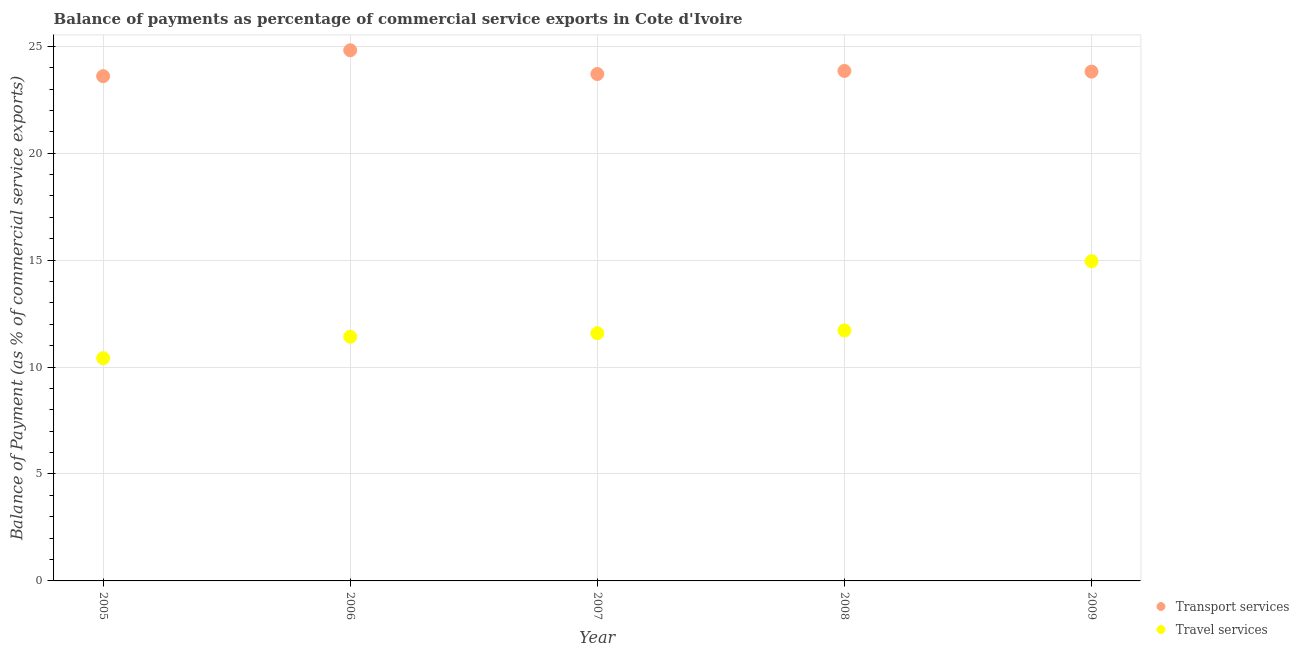Is the number of dotlines equal to the number of legend labels?
Offer a very short reply. Yes. What is the balance of payments of transport services in 2009?
Offer a very short reply. 23.82. Across all years, what is the maximum balance of payments of travel services?
Offer a terse response. 14.95. Across all years, what is the minimum balance of payments of transport services?
Offer a very short reply. 23.6. In which year was the balance of payments of transport services maximum?
Your answer should be compact. 2006. What is the total balance of payments of travel services in the graph?
Provide a short and direct response. 60.08. What is the difference between the balance of payments of transport services in 2005 and that in 2006?
Your response must be concise. -1.21. What is the difference between the balance of payments of transport services in 2007 and the balance of payments of travel services in 2006?
Give a very brief answer. 12.29. What is the average balance of payments of transport services per year?
Your answer should be compact. 23.96. In the year 2008, what is the difference between the balance of payments of travel services and balance of payments of transport services?
Give a very brief answer. -12.13. In how many years, is the balance of payments of travel services greater than 15 %?
Your answer should be very brief. 0. What is the ratio of the balance of payments of transport services in 2007 to that in 2009?
Your answer should be compact. 1. Is the balance of payments of travel services in 2006 less than that in 2008?
Offer a very short reply. Yes. What is the difference between the highest and the second highest balance of payments of transport services?
Your answer should be very brief. 0.97. What is the difference between the highest and the lowest balance of payments of travel services?
Offer a very short reply. 4.54. In how many years, is the balance of payments of transport services greater than the average balance of payments of transport services taken over all years?
Your response must be concise. 1. Is the sum of the balance of payments of transport services in 2007 and 2009 greater than the maximum balance of payments of travel services across all years?
Your answer should be very brief. Yes. Is the balance of payments of transport services strictly less than the balance of payments of travel services over the years?
Keep it short and to the point. No. How many years are there in the graph?
Your answer should be very brief. 5. Are the values on the major ticks of Y-axis written in scientific E-notation?
Ensure brevity in your answer.  No. Where does the legend appear in the graph?
Provide a succinct answer. Bottom right. What is the title of the graph?
Keep it short and to the point. Balance of payments as percentage of commercial service exports in Cote d'Ivoire. Does "Transport services" appear as one of the legend labels in the graph?
Make the answer very short. Yes. What is the label or title of the X-axis?
Provide a succinct answer. Year. What is the label or title of the Y-axis?
Ensure brevity in your answer.  Balance of Payment (as % of commercial service exports). What is the Balance of Payment (as % of commercial service exports) in Transport services in 2005?
Offer a terse response. 23.6. What is the Balance of Payment (as % of commercial service exports) in Travel services in 2005?
Ensure brevity in your answer.  10.42. What is the Balance of Payment (as % of commercial service exports) of Transport services in 2006?
Ensure brevity in your answer.  24.81. What is the Balance of Payment (as % of commercial service exports) of Travel services in 2006?
Provide a succinct answer. 11.42. What is the Balance of Payment (as % of commercial service exports) of Transport services in 2007?
Provide a short and direct response. 23.7. What is the Balance of Payment (as % of commercial service exports) of Travel services in 2007?
Your answer should be very brief. 11.58. What is the Balance of Payment (as % of commercial service exports) of Transport services in 2008?
Provide a succinct answer. 23.85. What is the Balance of Payment (as % of commercial service exports) of Travel services in 2008?
Offer a terse response. 11.72. What is the Balance of Payment (as % of commercial service exports) in Transport services in 2009?
Your answer should be very brief. 23.82. What is the Balance of Payment (as % of commercial service exports) of Travel services in 2009?
Provide a short and direct response. 14.95. Across all years, what is the maximum Balance of Payment (as % of commercial service exports) in Transport services?
Your response must be concise. 24.81. Across all years, what is the maximum Balance of Payment (as % of commercial service exports) of Travel services?
Your answer should be very brief. 14.95. Across all years, what is the minimum Balance of Payment (as % of commercial service exports) in Transport services?
Provide a succinct answer. 23.6. Across all years, what is the minimum Balance of Payment (as % of commercial service exports) of Travel services?
Provide a short and direct response. 10.42. What is the total Balance of Payment (as % of commercial service exports) in Transport services in the graph?
Make the answer very short. 119.79. What is the total Balance of Payment (as % of commercial service exports) of Travel services in the graph?
Your answer should be very brief. 60.08. What is the difference between the Balance of Payment (as % of commercial service exports) of Transport services in 2005 and that in 2006?
Provide a short and direct response. -1.21. What is the difference between the Balance of Payment (as % of commercial service exports) of Transport services in 2005 and that in 2007?
Your answer should be compact. -0.1. What is the difference between the Balance of Payment (as % of commercial service exports) in Travel services in 2005 and that in 2007?
Your answer should be very brief. -1.16. What is the difference between the Balance of Payment (as % of commercial service exports) of Transport services in 2005 and that in 2008?
Provide a succinct answer. -0.24. What is the difference between the Balance of Payment (as % of commercial service exports) in Travel services in 2005 and that in 2008?
Keep it short and to the point. -1.3. What is the difference between the Balance of Payment (as % of commercial service exports) in Transport services in 2005 and that in 2009?
Make the answer very short. -0.21. What is the difference between the Balance of Payment (as % of commercial service exports) of Travel services in 2005 and that in 2009?
Keep it short and to the point. -4.54. What is the difference between the Balance of Payment (as % of commercial service exports) in Transport services in 2006 and that in 2007?
Offer a very short reply. 1.11. What is the difference between the Balance of Payment (as % of commercial service exports) in Travel services in 2006 and that in 2007?
Offer a very short reply. -0.17. What is the difference between the Balance of Payment (as % of commercial service exports) in Transport services in 2006 and that in 2008?
Keep it short and to the point. 0.97. What is the difference between the Balance of Payment (as % of commercial service exports) in Travel services in 2006 and that in 2008?
Keep it short and to the point. -0.3. What is the difference between the Balance of Payment (as % of commercial service exports) of Transport services in 2006 and that in 2009?
Give a very brief answer. 1. What is the difference between the Balance of Payment (as % of commercial service exports) of Travel services in 2006 and that in 2009?
Make the answer very short. -3.54. What is the difference between the Balance of Payment (as % of commercial service exports) of Transport services in 2007 and that in 2008?
Keep it short and to the point. -0.14. What is the difference between the Balance of Payment (as % of commercial service exports) of Travel services in 2007 and that in 2008?
Keep it short and to the point. -0.13. What is the difference between the Balance of Payment (as % of commercial service exports) of Transport services in 2007 and that in 2009?
Keep it short and to the point. -0.11. What is the difference between the Balance of Payment (as % of commercial service exports) in Travel services in 2007 and that in 2009?
Your answer should be very brief. -3.37. What is the difference between the Balance of Payment (as % of commercial service exports) in Transport services in 2008 and that in 2009?
Ensure brevity in your answer.  0.03. What is the difference between the Balance of Payment (as % of commercial service exports) in Travel services in 2008 and that in 2009?
Your answer should be very brief. -3.24. What is the difference between the Balance of Payment (as % of commercial service exports) of Transport services in 2005 and the Balance of Payment (as % of commercial service exports) of Travel services in 2006?
Provide a succinct answer. 12.19. What is the difference between the Balance of Payment (as % of commercial service exports) in Transport services in 2005 and the Balance of Payment (as % of commercial service exports) in Travel services in 2007?
Your answer should be compact. 12.02. What is the difference between the Balance of Payment (as % of commercial service exports) in Transport services in 2005 and the Balance of Payment (as % of commercial service exports) in Travel services in 2008?
Your answer should be compact. 11.89. What is the difference between the Balance of Payment (as % of commercial service exports) of Transport services in 2005 and the Balance of Payment (as % of commercial service exports) of Travel services in 2009?
Give a very brief answer. 8.65. What is the difference between the Balance of Payment (as % of commercial service exports) in Transport services in 2006 and the Balance of Payment (as % of commercial service exports) in Travel services in 2007?
Offer a very short reply. 13.23. What is the difference between the Balance of Payment (as % of commercial service exports) in Transport services in 2006 and the Balance of Payment (as % of commercial service exports) in Travel services in 2008?
Provide a succinct answer. 13.1. What is the difference between the Balance of Payment (as % of commercial service exports) of Transport services in 2006 and the Balance of Payment (as % of commercial service exports) of Travel services in 2009?
Offer a terse response. 9.86. What is the difference between the Balance of Payment (as % of commercial service exports) of Transport services in 2007 and the Balance of Payment (as % of commercial service exports) of Travel services in 2008?
Provide a short and direct response. 11.99. What is the difference between the Balance of Payment (as % of commercial service exports) in Transport services in 2007 and the Balance of Payment (as % of commercial service exports) in Travel services in 2009?
Your response must be concise. 8.75. What is the difference between the Balance of Payment (as % of commercial service exports) in Transport services in 2008 and the Balance of Payment (as % of commercial service exports) in Travel services in 2009?
Your answer should be compact. 8.9. What is the average Balance of Payment (as % of commercial service exports) of Transport services per year?
Offer a very short reply. 23.96. What is the average Balance of Payment (as % of commercial service exports) in Travel services per year?
Make the answer very short. 12.02. In the year 2005, what is the difference between the Balance of Payment (as % of commercial service exports) of Transport services and Balance of Payment (as % of commercial service exports) of Travel services?
Keep it short and to the point. 13.19. In the year 2006, what is the difference between the Balance of Payment (as % of commercial service exports) in Transport services and Balance of Payment (as % of commercial service exports) in Travel services?
Your answer should be very brief. 13.4. In the year 2007, what is the difference between the Balance of Payment (as % of commercial service exports) of Transport services and Balance of Payment (as % of commercial service exports) of Travel services?
Make the answer very short. 12.12. In the year 2008, what is the difference between the Balance of Payment (as % of commercial service exports) of Transport services and Balance of Payment (as % of commercial service exports) of Travel services?
Make the answer very short. 12.13. In the year 2009, what is the difference between the Balance of Payment (as % of commercial service exports) in Transport services and Balance of Payment (as % of commercial service exports) in Travel services?
Offer a very short reply. 8.86. What is the ratio of the Balance of Payment (as % of commercial service exports) in Transport services in 2005 to that in 2006?
Make the answer very short. 0.95. What is the ratio of the Balance of Payment (as % of commercial service exports) in Travel services in 2005 to that in 2006?
Your answer should be very brief. 0.91. What is the ratio of the Balance of Payment (as % of commercial service exports) in Travel services in 2005 to that in 2007?
Your answer should be compact. 0.9. What is the ratio of the Balance of Payment (as % of commercial service exports) of Travel services in 2005 to that in 2008?
Provide a short and direct response. 0.89. What is the ratio of the Balance of Payment (as % of commercial service exports) in Travel services in 2005 to that in 2009?
Your response must be concise. 0.7. What is the ratio of the Balance of Payment (as % of commercial service exports) of Transport services in 2006 to that in 2007?
Provide a succinct answer. 1.05. What is the ratio of the Balance of Payment (as % of commercial service exports) of Travel services in 2006 to that in 2007?
Ensure brevity in your answer.  0.99. What is the ratio of the Balance of Payment (as % of commercial service exports) in Transport services in 2006 to that in 2008?
Give a very brief answer. 1.04. What is the ratio of the Balance of Payment (as % of commercial service exports) in Travel services in 2006 to that in 2008?
Give a very brief answer. 0.97. What is the ratio of the Balance of Payment (as % of commercial service exports) of Transport services in 2006 to that in 2009?
Give a very brief answer. 1.04. What is the ratio of the Balance of Payment (as % of commercial service exports) in Travel services in 2006 to that in 2009?
Ensure brevity in your answer.  0.76. What is the ratio of the Balance of Payment (as % of commercial service exports) of Travel services in 2007 to that in 2008?
Your response must be concise. 0.99. What is the ratio of the Balance of Payment (as % of commercial service exports) in Transport services in 2007 to that in 2009?
Provide a succinct answer. 1. What is the ratio of the Balance of Payment (as % of commercial service exports) of Travel services in 2007 to that in 2009?
Offer a terse response. 0.77. What is the ratio of the Balance of Payment (as % of commercial service exports) of Transport services in 2008 to that in 2009?
Make the answer very short. 1. What is the ratio of the Balance of Payment (as % of commercial service exports) of Travel services in 2008 to that in 2009?
Offer a very short reply. 0.78. What is the difference between the highest and the second highest Balance of Payment (as % of commercial service exports) in Transport services?
Your response must be concise. 0.97. What is the difference between the highest and the second highest Balance of Payment (as % of commercial service exports) in Travel services?
Make the answer very short. 3.24. What is the difference between the highest and the lowest Balance of Payment (as % of commercial service exports) in Transport services?
Provide a succinct answer. 1.21. What is the difference between the highest and the lowest Balance of Payment (as % of commercial service exports) in Travel services?
Keep it short and to the point. 4.54. 